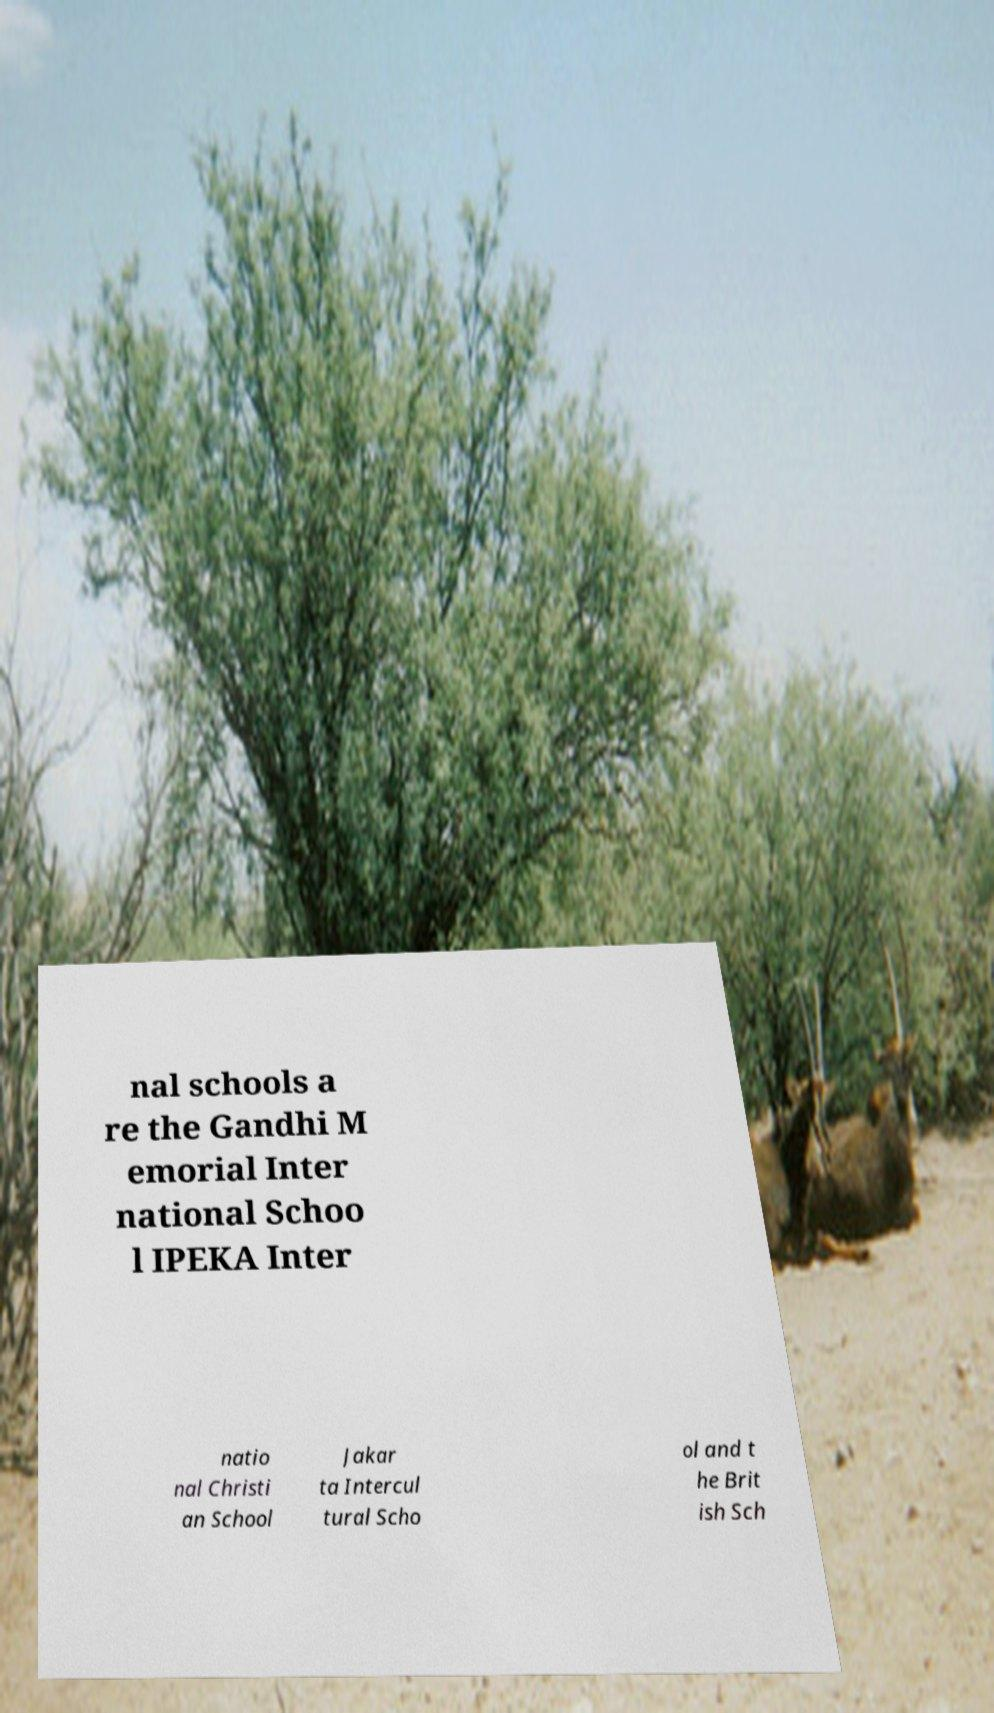Please identify and transcribe the text found in this image. nal schools a re the Gandhi M emorial Inter national Schoo l IPEKA Inter natio nal Christi an School Jakar ta Intercul tural Scho ol and t he Brit ish Sch 